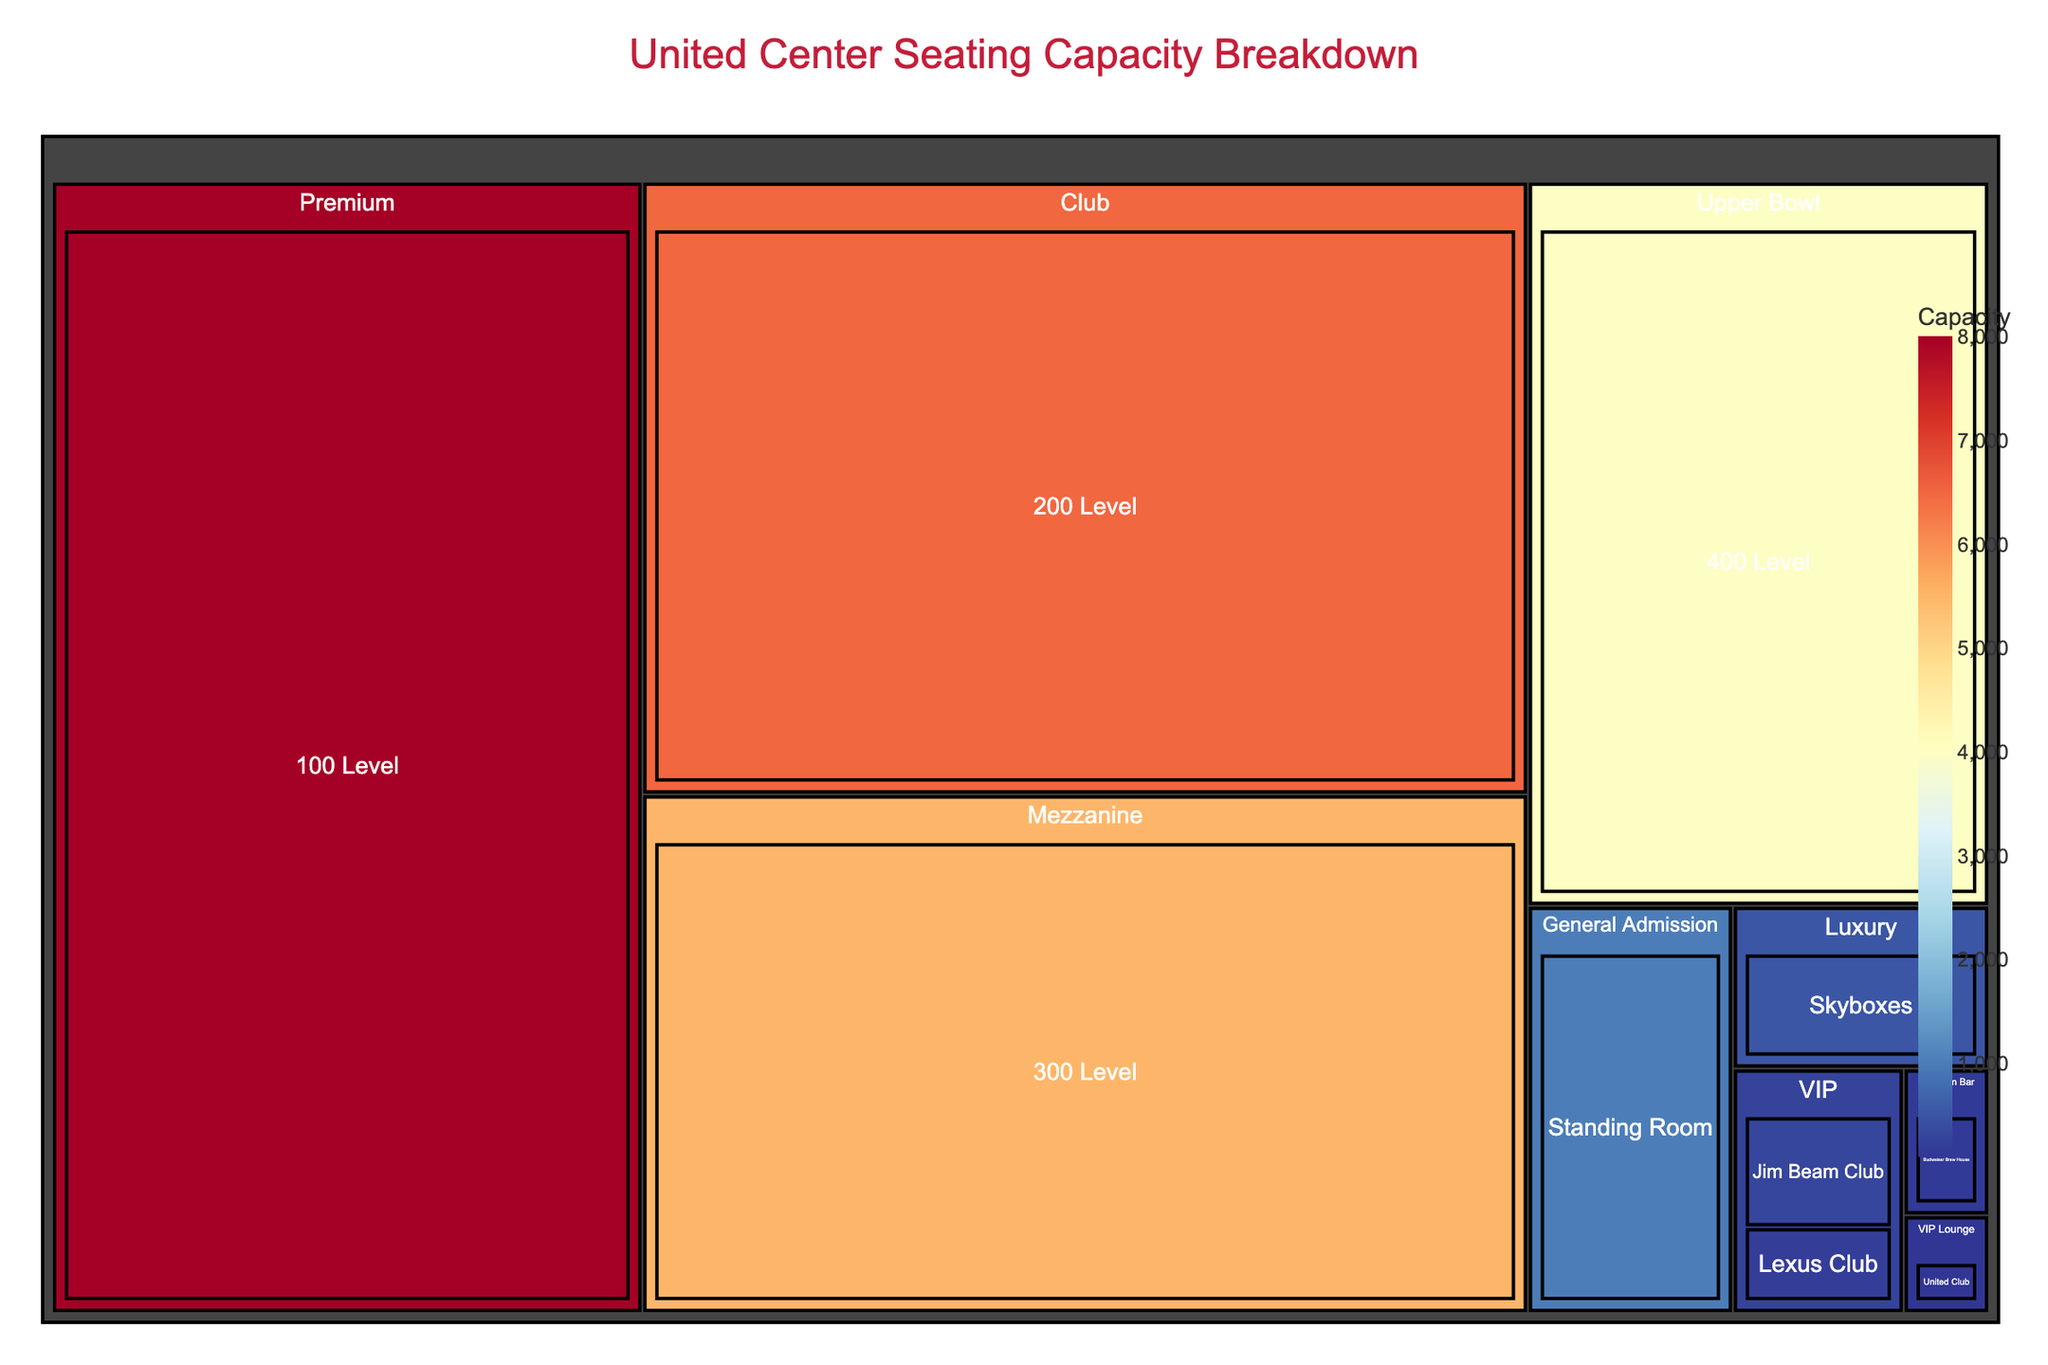What's the title of the plot? The title is prominently displayed at the top of the figure, usually in a larger and bold font.
Answer: United Center Seating Capacity Breakdown Which section has the highest seating capacity? The section with the highest seating capacity is the largest rectangle in the treemap.
Answer: 100 Level Which section has the lowest seating capacity among VIP tiers? Look for the smallest rectangle labeled with VIP tier sections and check their capacity.
Answer: United Club What is the combined seating capacity of all the VIP level sections? Add the capacities of Jim Beam Club (300), Lexus Club (200), and United Club (100). So, 300 + 200 + 100 = 600.
Answer: 600 How does the capacity of the Skyboxes compare to the Standing Room? Compare the capacity shown for Skyboxes (500) and Standing Room (1000).
Answer: Skyboxes have a lower capacity than Standing Room By how much does the capacity of the 200 Level exceed the 300 Level? Subtract the seating capacity of the 300 Level (5500) from the 200 Level (6500). So, 6500 - 5500 = 1000.
Answer: 1000 Which price tier has the largest total seating capacity? Add the capacities of all sections within each price tier and compare the totals. Premium: 8000 (100 Level) + 150 (Budweiser Brew House) = 8150, Club: 6500 (200 Level), Mezzanine: 5500 (300 Level), Upper Bowl: 4000 (400 Level), General Admission: 1000 (Standing Room), Luxury: 500 (Skyboxes), VIP: 300 (Jim Beam Club) + 200 (Lexus Club) + 100 (United Club) = 600 + 100 = 900. Therefore, Premium has the largest total seating capacity.
Answer: Premium What is the distribution of seating capacity across different price tiers? The treemap breaks down capacity by price tier and section within each tier. Look at the relative sizes of the rectangles corresponding to each price tier.
Answer: Varies across Premium, Club, Mezzanine, Upper Bowl, General Admission, Luxury, and VIP categories If Standing Room and United Club capacities are combined, how does their total capacity compare to the 400 Level? Add the capacities of Standing Room (1000) and United Club (100). Then compare the sum to the 400 Level. 1000 + 100 = 1100 which is higher than the 4000 of the 400 Level.
Answer: Higher 